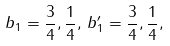<formula> <loc_0><loc_0><loc_500><loc_500>b _ { 1 } = \frac { 3 } { 4 } , \frac { 1 } { 4 } , \, b _ { 1 } ^ { \prime } = \frac { 3 } { 4 } , \frac { 1 } { 4 } ,</formula> 